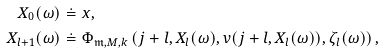Convert formula to latex. <formula><loc_0><loc_0><loc_500><loc_500>X _ { 0 } ( \omega ) & \doteq x , \\ X _ { l + 1 } ( \omega ) & \doteq \Phi _ { \mathfrak { m } , M , k } \left ( j + l , X _ { l } ( \omega ) , v ( j + l , X _ { l } ( \omega ) ) , \zeta _ { l } ( \omega ) \right ) ,</formula> 